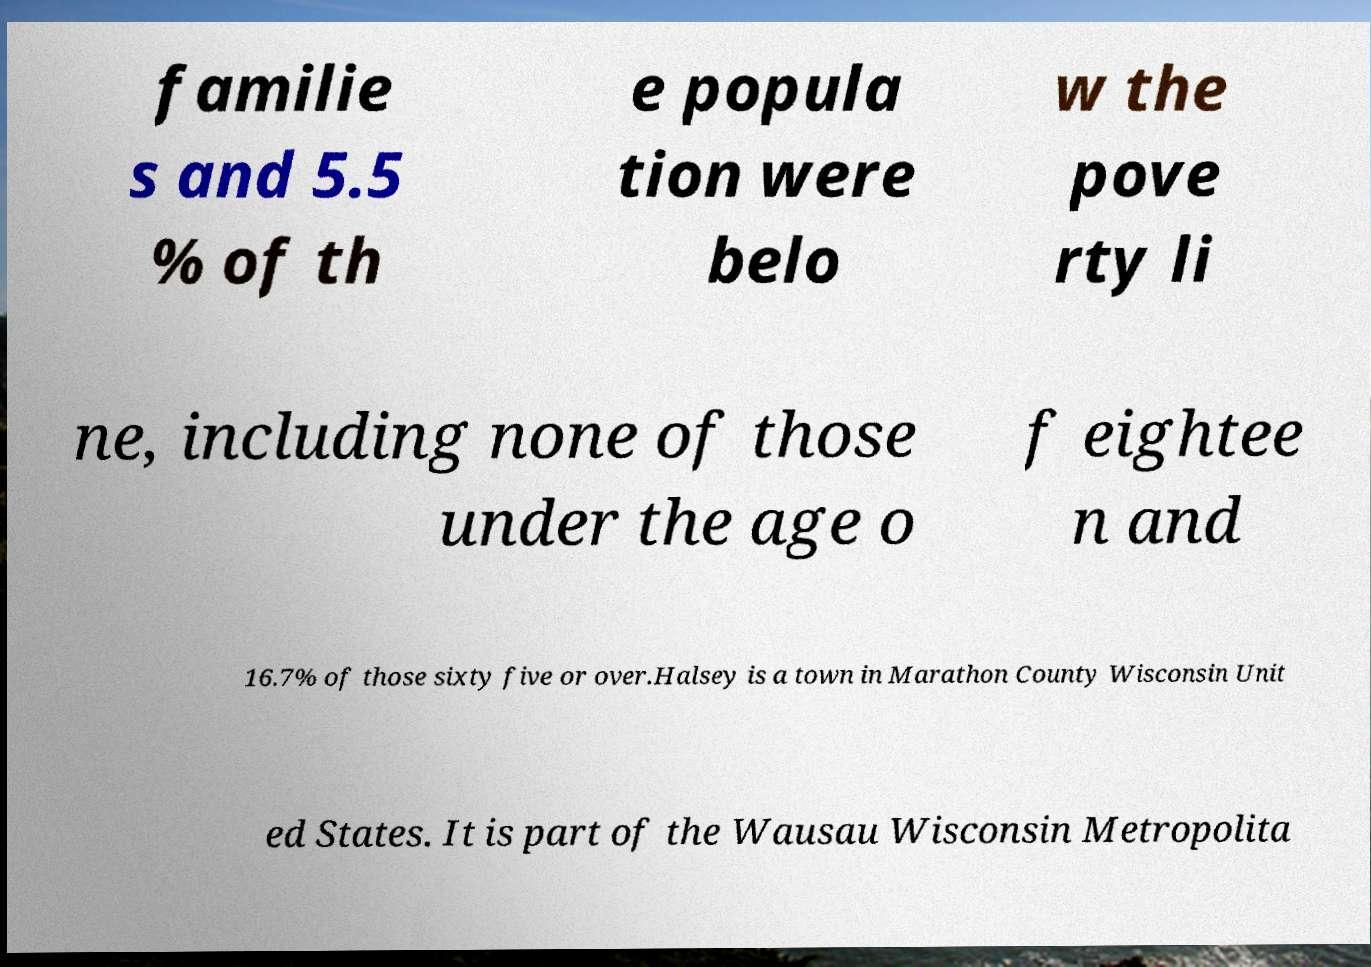What messages or text are displayed in this image? I need them in a readable, typed format. familie s and 5.5 % of th e popula tion were belo w the pove rty li ne, including none of those under the age o f eightee n and 16.7% of those sixty five or over.Halsey is a town in Marathon County Wisconsin Unit ed States. It is part of the Wausau Wisconsin Metropolita 